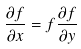<formula> <loc_0><loc_0><loc_500><loc_500>\frac { \partial f } { \partial x } = f \frac { \partial f } { \partial y }</formula> 